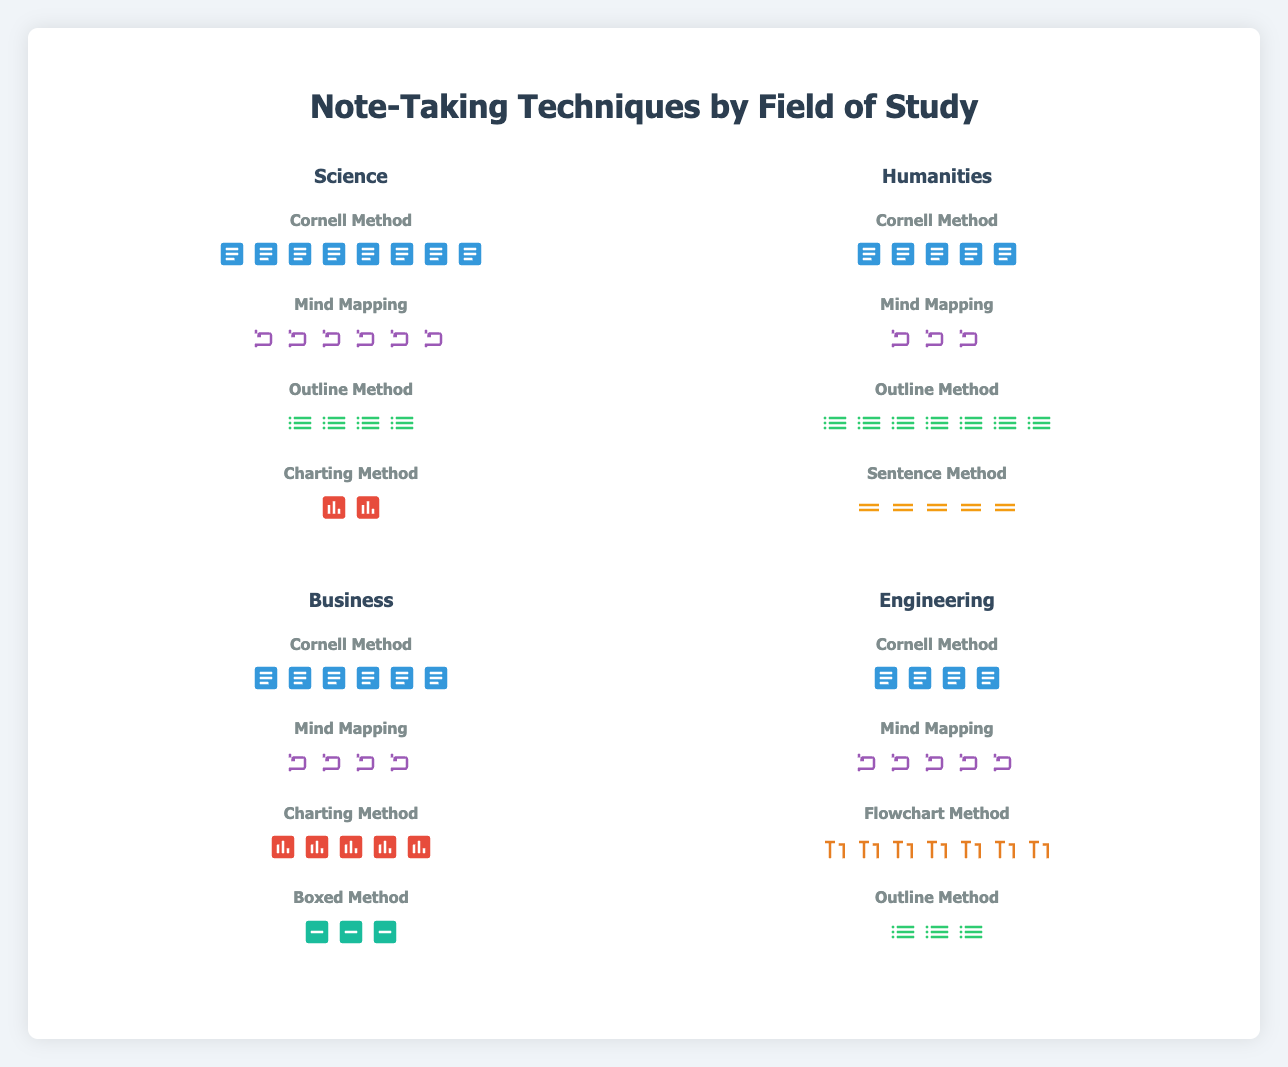What is the most frequently used note-taking technique in the Humanities field? By examining the Humanities section, we see that the Outline Method has the most icons, which represent its frequency.
Answer: Outline Method Which field has the highest frequency of using the Cornell Method? Compare the number of Cornell icons in each field. The Science field has 8 Cornell icons, more than any other field.
Answer: Science How many different note-taking techniques are used in the Business field? Count the number of unique technique names listed under the Business section.
Answer: 4 In which field is the Flowchart Method used, and what is its frequency? Identify the field that lists the Flowchart Method and the number of corresponding icons. It appears only in Engineering with 7 icons.
Answer: Engineering, 7 What is the total frequency of the Outline Method across all fields? Add the frequencies of the Outline Method for each field: Science (4), Humanities (7), Engineering (3).
Answer: 14 Which note-taking technique has the lowest frequency in Science? Look for the technique in Science with the fewest icons. The Charting Method has the lowest frequency with 2 icons.
Answer: Charting Method Compare the frequency of the Mind Mapping technique in Science and Humanities. Which field uses it more frequently? Count and compare the Mind Mapping icons in both Science (6) and Humanities (3). Science has more.
Answer: Science How many fields utilize the Charting Method? Count the number of fields where the Charting Method appears. It's used in Science and Business.
Answer: 2 Which field employs the least diverse range of note-taking techniques? Determine the field with the fewest unique note-taking techniques listed.
Answer: Engineering 